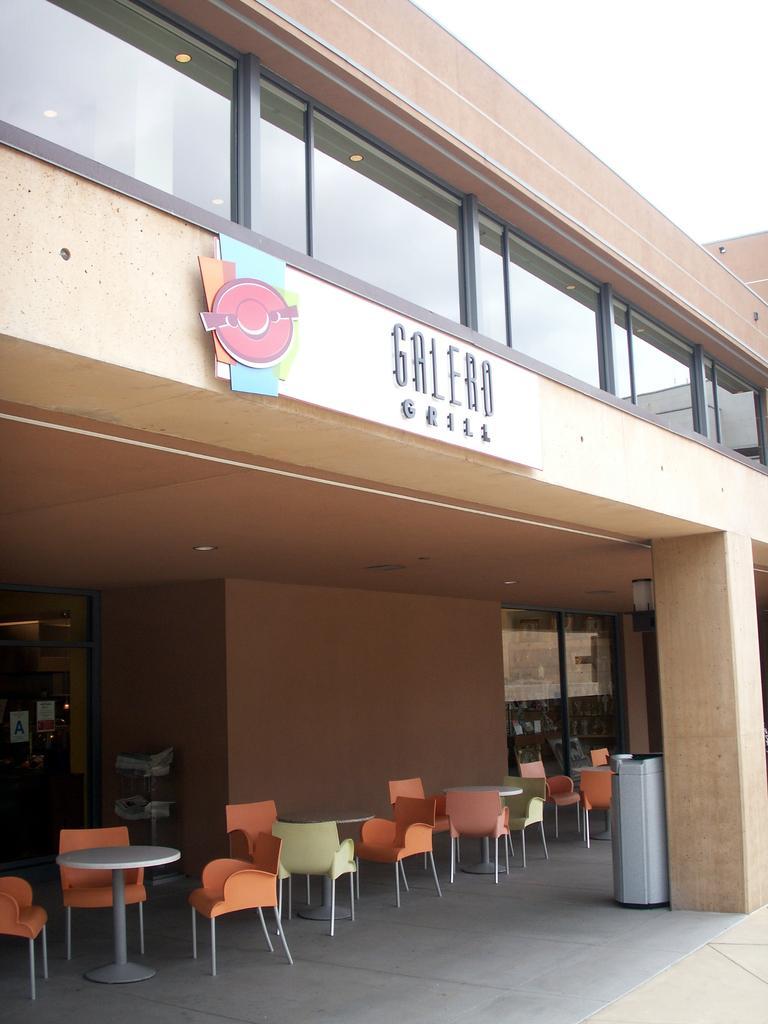Please provide a concise description of this image. Here we can see building, pillar, bin, chairs, tables and glass windows. 